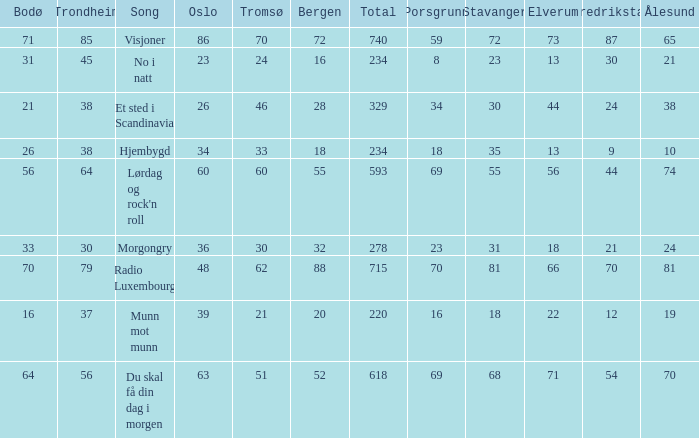What is the lowest total? 220.0. 